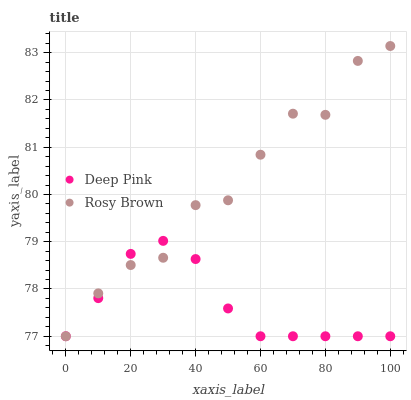Does Deep Pink have the minimum area under the curve?
Answer yes or no. Yes. Does Rosy Brown have the maximum area under the curve?
Answer yes or no. Yes. Does Deep Pink have the maximum area under the curve?
Answer yes or no. No. Is Deep Pink the smoothest?
Answer yes or no. Yes. Is Rosy Brown the roughest?
Answer yes or no. Yes. Is Deep Pink the roughest?
Answer yes or no. No. Does Rosy Brown have the lowest value?
Answer yes or no. Yes. Does Rosy Brown have the highest value?
Answer yes or no. Yes. Does Deep Pink have the highest value?
Answer yes or no. No. Does Rosy Brown intersect Deep Pink?
Answer yes or no. Yes. Is Rosy Brown less than Deep Pink?
Answer yes or no. No. Is Rosy Brown greater than Deep Pink?
Answer yes or no. No. 